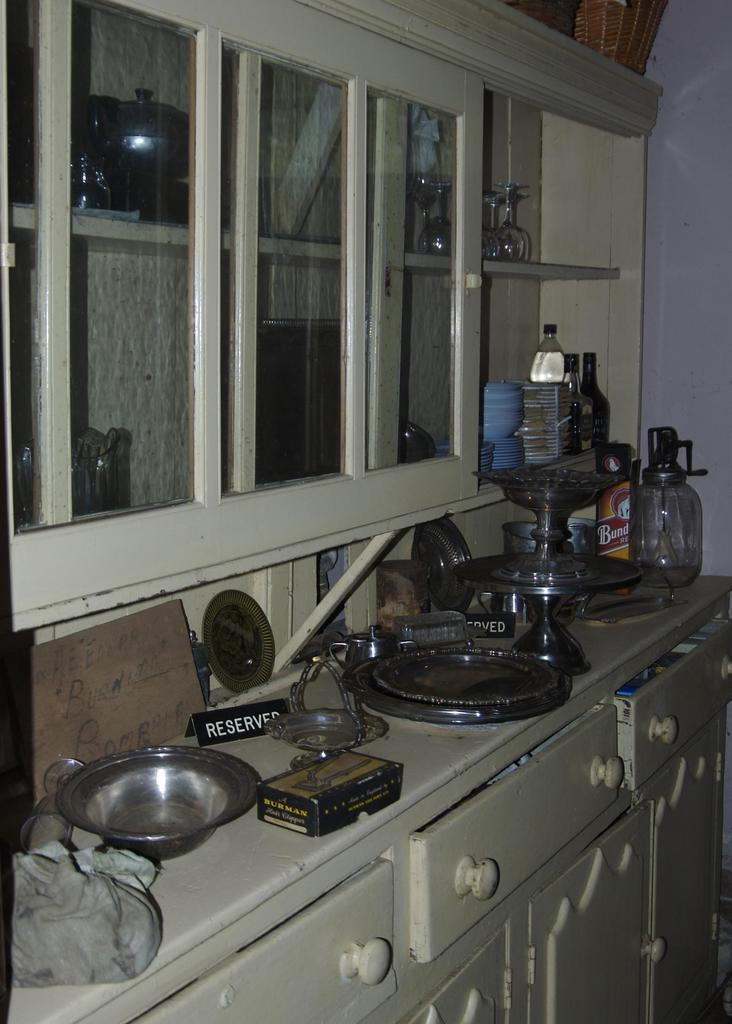<image>
Write a terse but informative summary of the picture. A counter with misc stuff on it such as a RESERVED table marker and a box by BURMAN. 